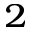<formula> <loc_0><loc_0><loc_500><loc_500>^ { 2 }</formula> 